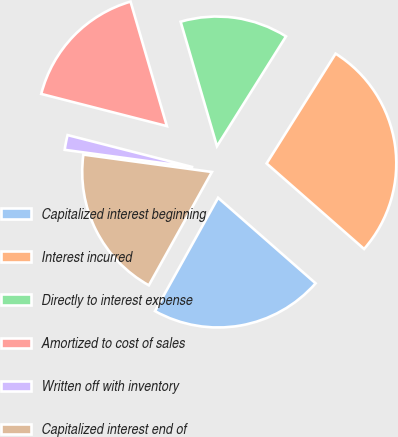Convert chart to OTSL. <chart><loc_0><loc_0><loc_500><loc_500><pie_chart><fcel>Capitalized interest beginning<fcel>Interest incurred<fcel>Directly to interest expense<fcel>Amortized to cost of sales<fcel>Written off with inventory<fcel>Capitalized interest end of<nl><fcel>21.62%<fcel>27.53%<fcel>13.45%<fcel>16.49%<fcel>1.85%<fcel>19.06%<nl></chart> 